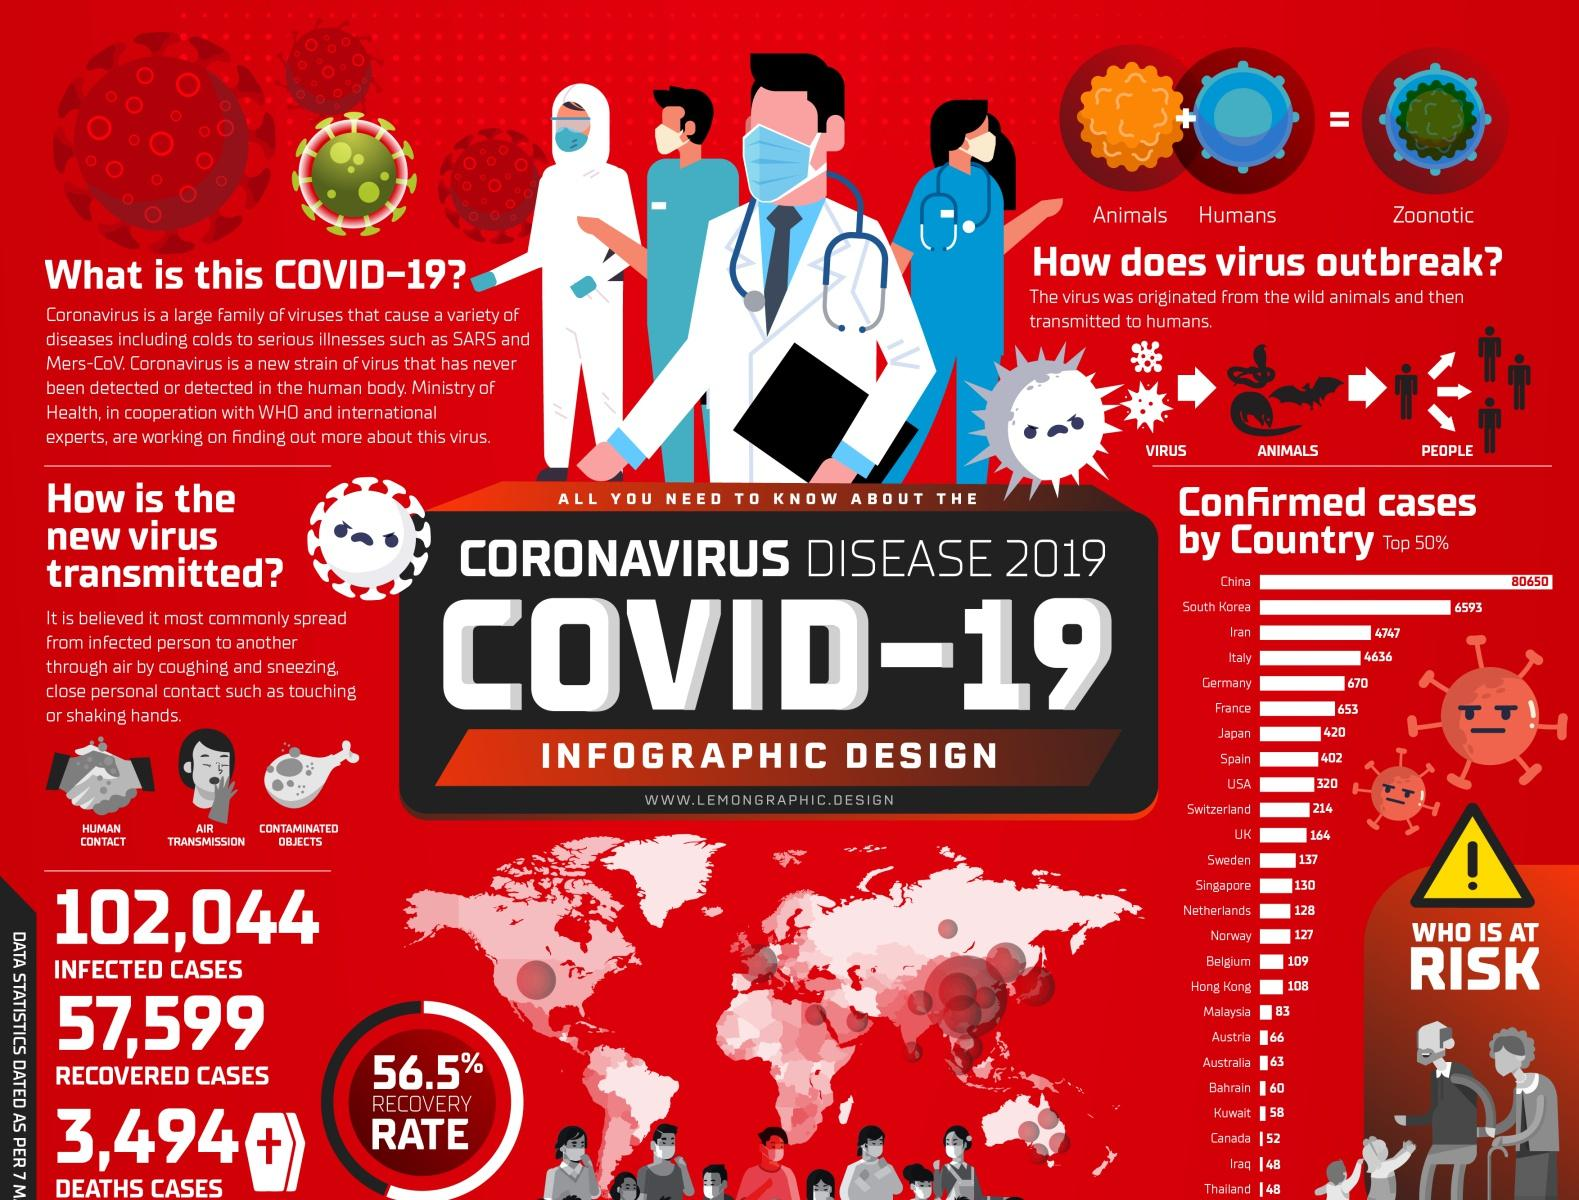List a handful of essential elements in this visual. In total, 57,599 cases of COVID-19 have been recovered as of February 2023. There were 3,494 reported death cases. The recovery rate is 56.5%. There are three ways in which viruses can be transmitted: through human contact, air transmission, and contaminated objects. There have been 102,044 reported cases of infected individuals as of [date]. 